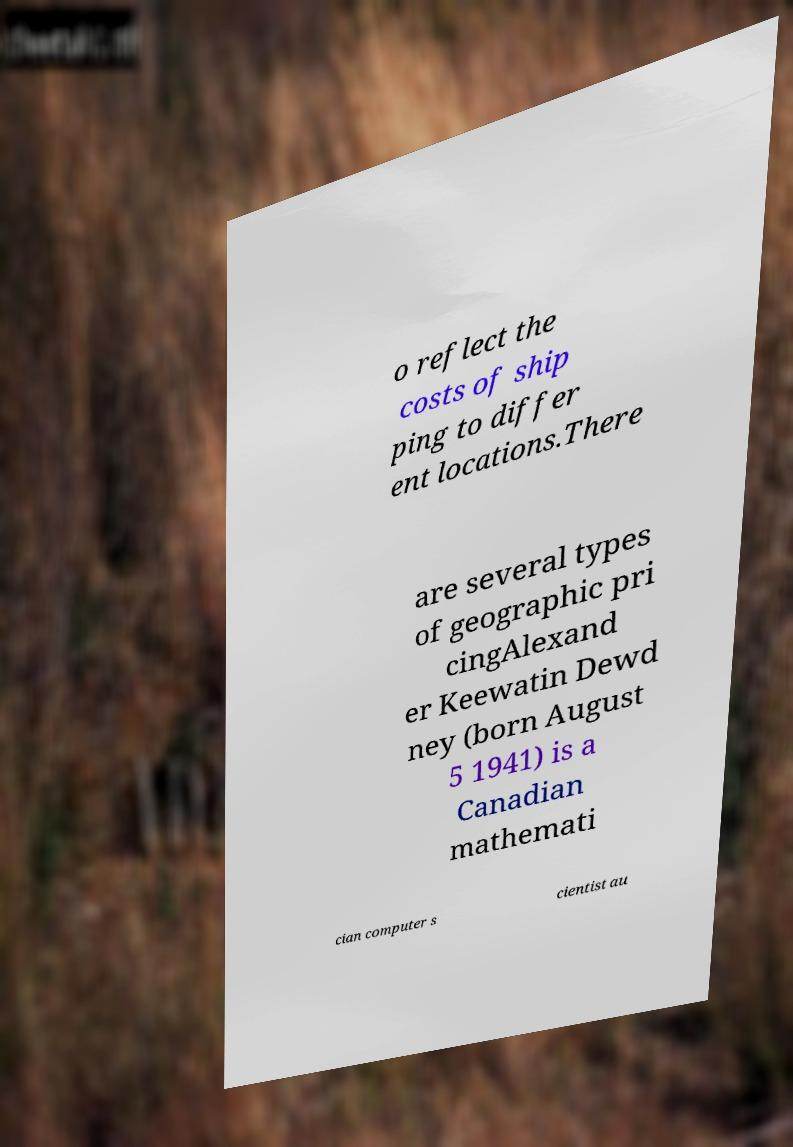Can you accurately transcribe the text from the provided image for me? o reflect the costs of ship ping to differ ent locations.There are several types of geographic pri cingAlexand er Keewatin Dewd ney (born August 5 1941) is a Canadian mathemati cian computer s cientist au 